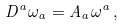Convert formula to latex. <formula><loc_0><loc_0><loc_500><loc_500>D ^ { a } \omega _ { a } = A _ { a } \omega ^ { a } \, ,</formula> 